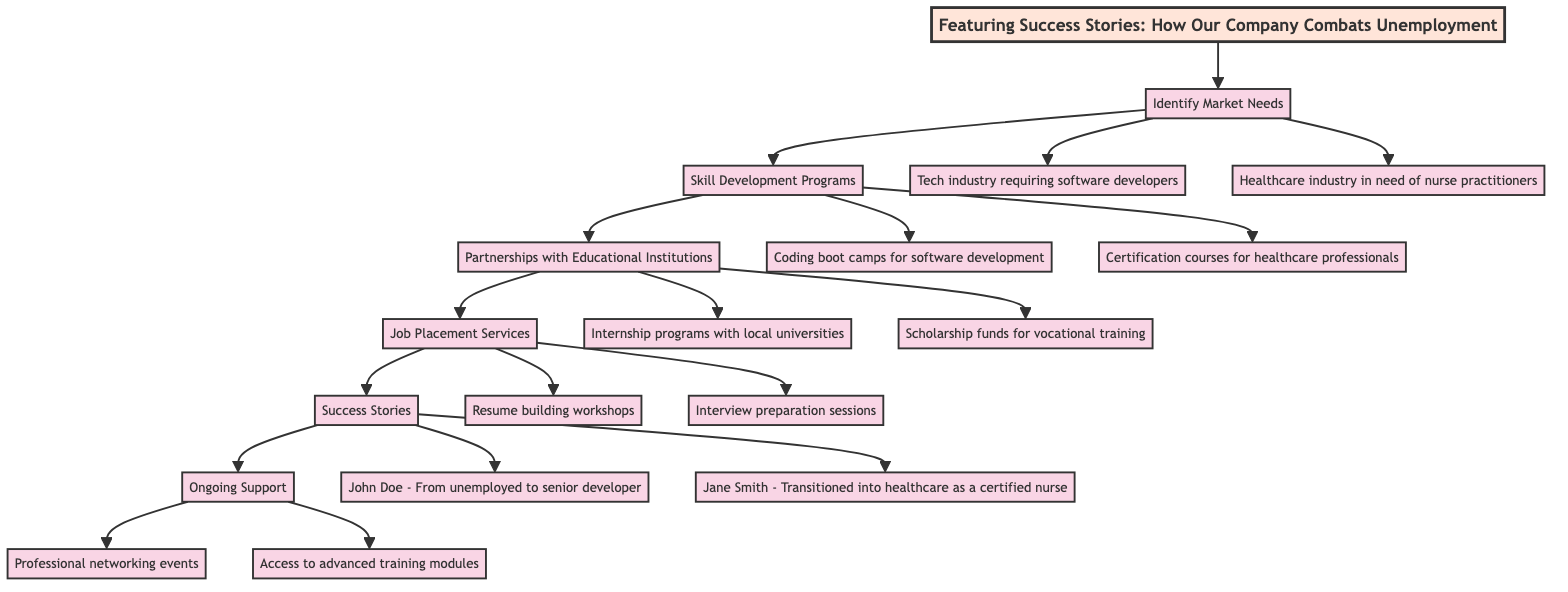What is the first block in the diagram? The first block in the diagram is connected directly to the title and is labeled "Identify Market Needs." This is the initial step in the flow of the solution to combat unemployment.
Answer: Identify Market Needs How many blocks are present in the diagram? The diagram contains a total of six blocks, which includes "Identify Market Needs," "Skill Development Programs," "Partnerships with Educational Institutions," "Job Placement Services," "Success Stories," and "Ongoing Support."
Answer: Six What are the two specific examples of skills needed from the "Identify Market Needs" block? From the "Identify Market Needs" block, the two specific examples given are "Tech industry requiring software developers" and "Healthcare industry in need of nurse practitioners." These examples highlight the demand for particular skills in various industries.
Answer: Tech industry requiring software developers, Healthcare industry in need of nurse practitioners Which block follows "Skill Development Programs"? The block that follows "Skill Development Programs" in the flow is "Partnerships with Educational Institutions," establishing a direct connection from skill development to educational collaborations.
Answer: Partnerships with Educational Institutions What type of programs are provided under "Skill Development Programs"? Under "Skill Development Programs," the two types of training programs mentioned are "Coding boot camps for software development" and "Certification courses for healthcare professionals," both designed to equip individuals with specific skills.
Answer: Coding boot camps for software development, Certification courses for healthcare professionals How does "Job Placement Services" assist graduates? "Job Placement Services" assists graduates primarily through two methods: "Resume building workshops" and "Interview preparation sessions." These services aim to enhance employability skills and prepare individuals for securing jobs.
Answer: Resume building workshops, Interview preparation sessions Who are the two individuals highlighted in the "Success Stories" block? The "Success Stories" block highlights two individuals: "John Doe - From unemployed to senior developer at a tech firm" and "Jane Smith - Transitioned into healthcare as a certified nurse." These examples demonstrate the successful outcomes of the initiatives.
Answer: John Doe, Jane Smith What ongoing support is provided post-employment? The ongoing support includes "Professional networking events" and "Access to advanced training modules," which offer continual career growth opportunities for individuals after they secure employment.
Answer: Professional networking events, Access to advanced training modules 